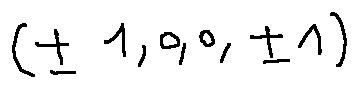<formula> <loc_0><loc_0><loc_500><loc_500>( \pm 1 , 0 , 0 , \pm 1 )</formula> 